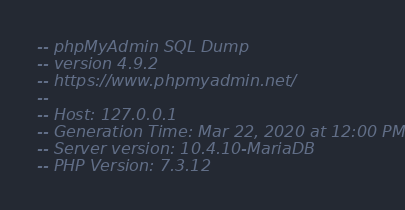<code> <loc_0><loc_0><loc_500><loc_500><_SQL_>-- phpMyAdmin SQL Dump
-- version 4.9.2
-- https://www.phpmyadmin.net/
--
-- Host: 127.0.0.1
-- Generation Time: Mar 22, 2020 at 12:00 PM
-- Server version: 10.4.10-MariaDB
-- PHP Version: 7.3.12
</code> 